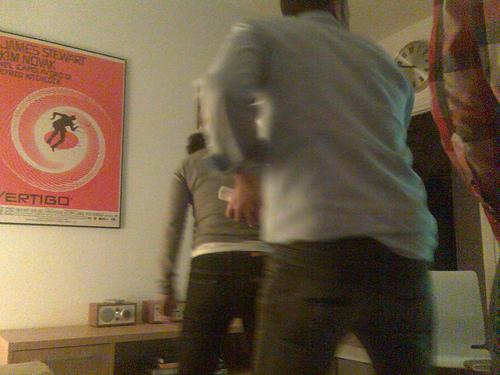What form of vintage media do the people in the living room enjoy? Please explain your reasoning. movies. The people in the living room enjoy watching movies. 